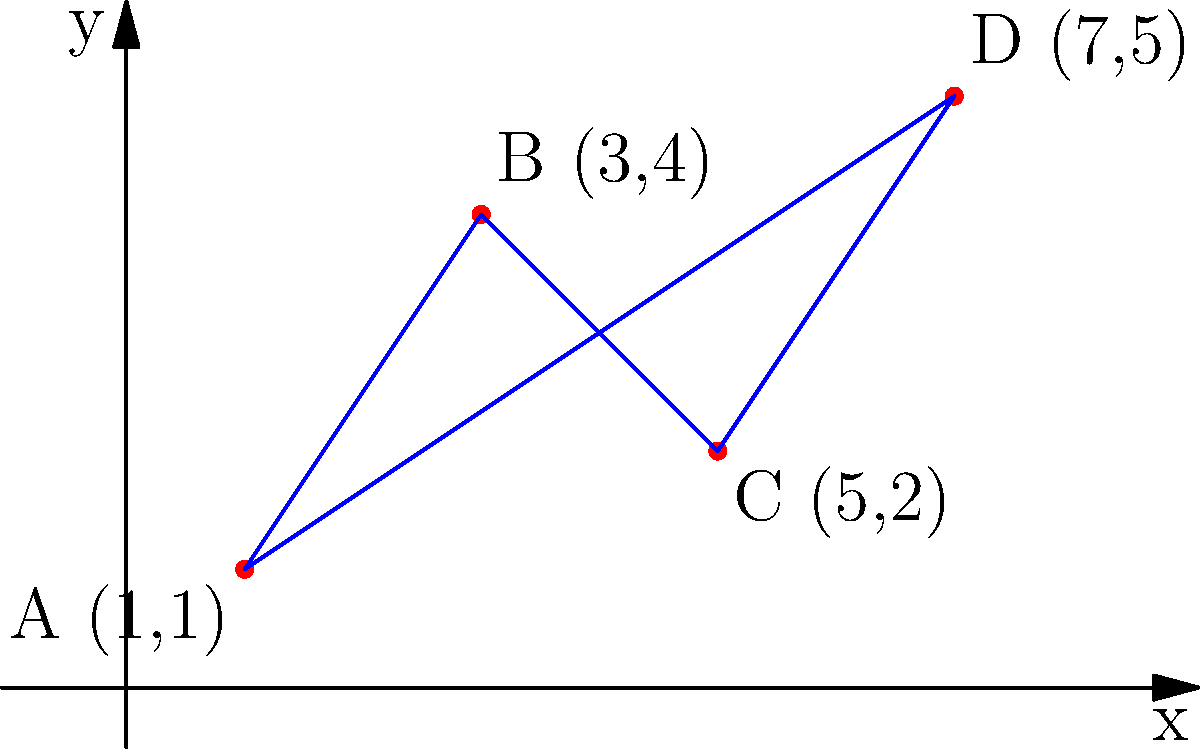As a local business owner, you're working with the police to optimize their patrol route. Four businesses, including yours, are located at points A(1,1), B(3,4), C(5,2), and D(7,5) on a coordinate grid. The police want to visit all locations and return to the starting point. Calculate the total distance of the shortest possible patrol route, assuming they travel in straight lines between points. To find the shortest patrol route, we need to calculate the distances between all points and determine the shortest path that visits all locations once before returning to the start. This is known as the "Traveling Salesman Problem."

For this small set of points, we can calculate all possible routes and choose the shortest one. The possible routes are:

1. A-B-C-D-A
2. A-B-D-C-A
3. A-C-B-D-A
4. A-C-D-B-A
5. A-D-B-C-A
6. A-D-C-B-A

Let's calculate the distance of each segment using the distance formula:
$d = \sqrt{(x_2-x_1)^2 + (y_2-y_1)^2}$

AB: $\sqrt{(3-1)^2 + (4-1)^2} = \sqrt{13}$
BC: $\sqrt{(5-3)^2 + (2-4)^2} = \sqrt{8}$
CD: $\sqrt{(7-5)^2 + (5-2)^2} = \sqrt{13}$
DA: $\sqrt{(1-7)^2 + (1-5)^2} = \sqrt{52}$
AC: $\sqrt{(5-1)^2 + (2-1)^2} = \sqrt{17}$
BD: $\sqrt{(7-3)^2 + (5-4)^2} = \sqrt{17}$

Now, let's calculate the total distance for each route:

1. A-B-C-D-A: $\sqrt{13} + \sqrt{8} + \sqrt{13} + \sqrt{52} = 2\sqrt{13} + \sqrt{8} + \sqrt{52}$
2. A-B-D-C-A: $\sqrt{13} + \sqrt{17} + \sqrt{13} + \sqrt{17} = 2\sqrt{13} + 2\sqrt{17}$
3. A-C-B-D-A: $\sqrt{17} + \sqrt{8} + \sqrt{17} + \sqrt{52} = 2\sqrt{17} + \sqrt{8} + \sqrt{52}$
4. A-C-D-B-A: $\sqrt{17} + \sqrt{13} + \sqrt{17} + \sqrt{13} = 2\sqrt{17} + 2\sqrt{13}$
5. A-D-B-C-A: $\sqrt{52} + \sqrt{17} + \sqrt{8} + \sqrt{17} = \sqrt{52} + 2\sqrt{17} + \sqrt{8}$
6. A-D-C-B-A: $\sqrt{52} + \sqrt{13} + \sqrt{8} + \sqrt{13} = \sqrt{52} + 2\sqrt{13} + \sqrt{8}$

The shortest route is A-B-D-C-A or A-C-D-B-A, both with a total distance of $2\sqrt{17} + 2\sqrt{13}$.
Answer: $2\sqrt{17} + 2\sqrt{13}$ 